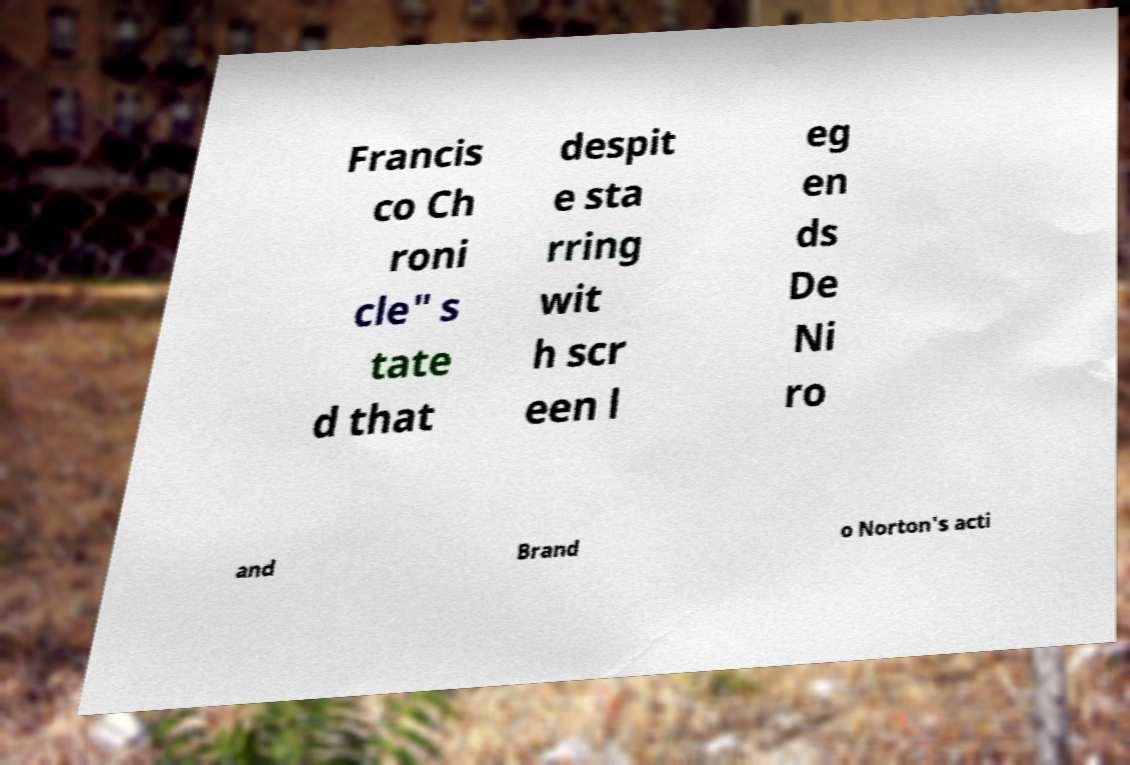For documentation purposes, I need the text within this image transcribed. Could you provide that? Francis co Ch roni cle" s tate d that despit e sta rring wit h scr een l eg en ds De Ni ro and Brand o Norton's acti 